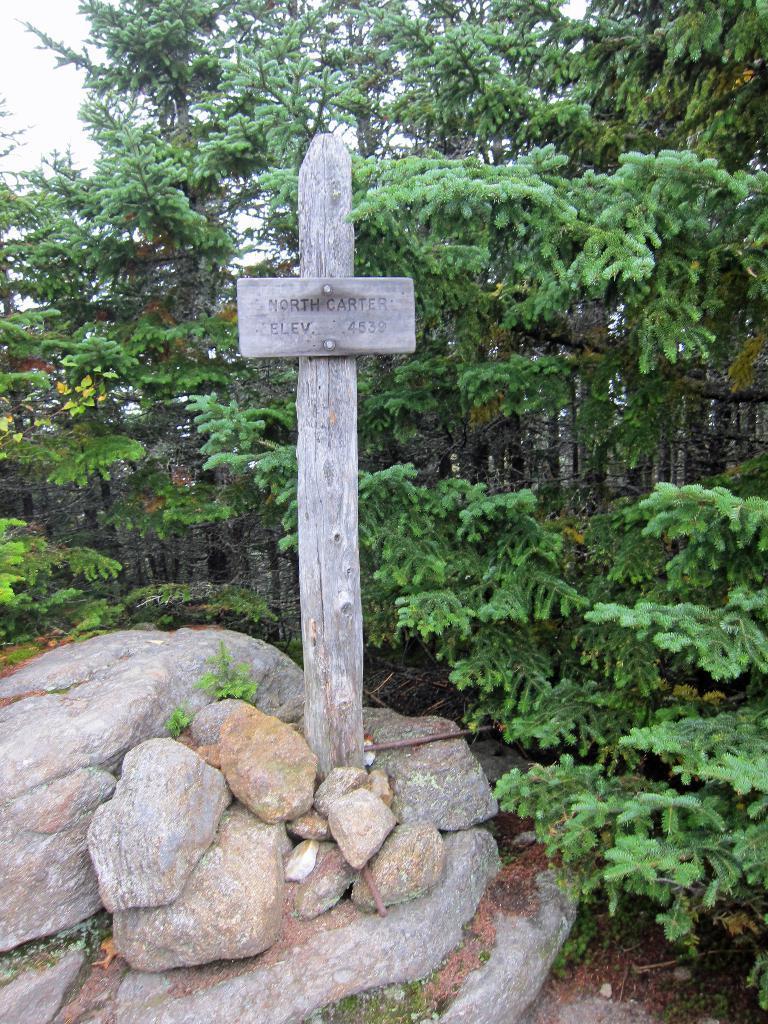Can you describe this image briefly? In this picture I can see the wooden board on the wooden pole. At the bottom I can see the stones. In the back I can see the trees, plants and grass. In the top left I can see the sky. 